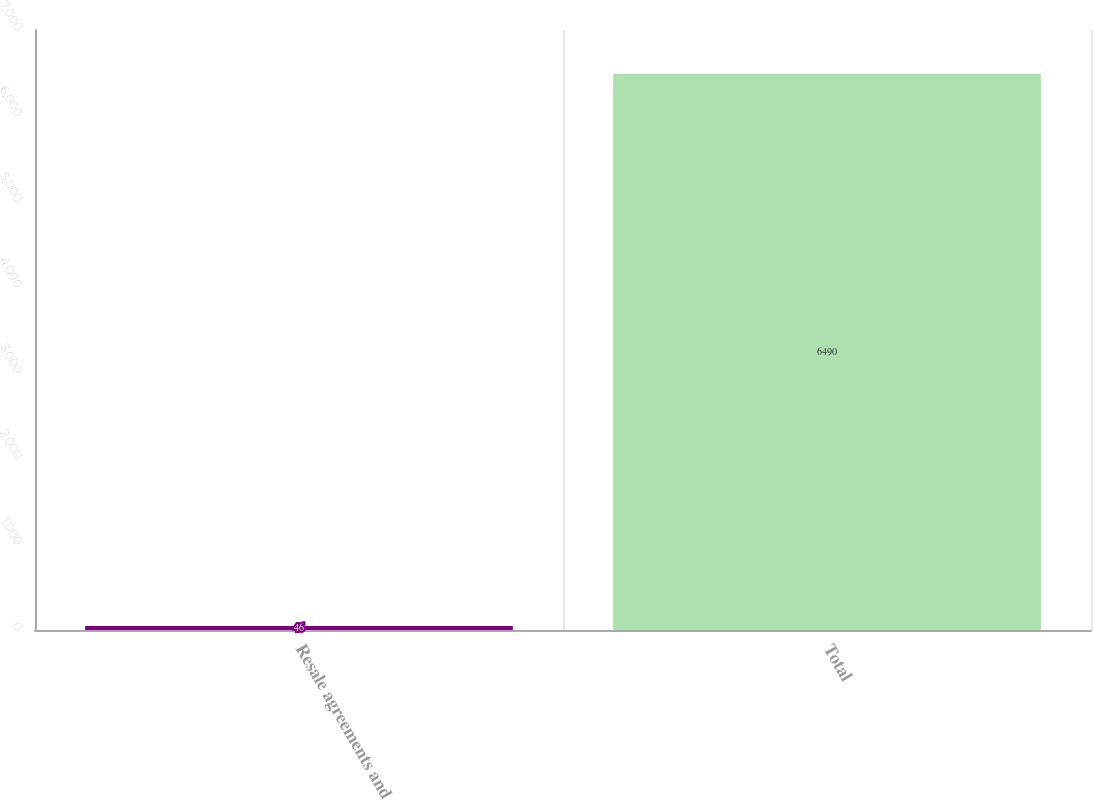Convert chart to OTSL. <chart><loc_0><loc_0><loc_500><loc_500><bar_chart><fcel>Resale agreements and<fcel>Total<nl><fcel>46<fcel>6490<nl></chart> 